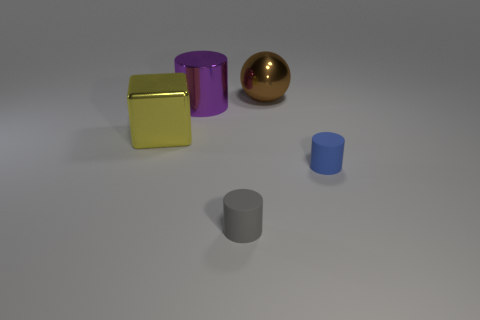Add 1 green things. How many objects exist? 6 Subtract all blocks. How many objects are left? 4 Subtract all large yellow metal cylinders. Subtract all cylinders. How many objects are left? 2 Add 3 brown balls. How many brown balls are left? 4 Add 4 large objects. How many large objects exist? 7 Subtract 0 purple cubes. How many objects are left? 5 